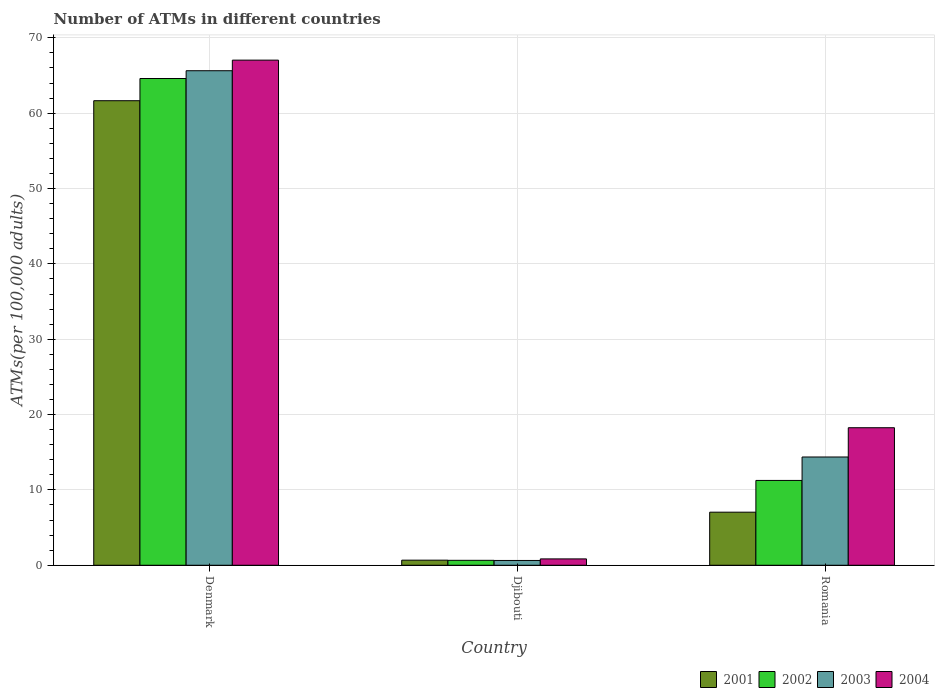How many groups of bars are there?
Provide a succinct answer. 3. Are the number of bars per tick equal to the number of legend labels?
Make the answer very short. Yes. How many bars are there on the 2nd tick from the left?
Keep it short and to the point. 4. How many bars are there on the 3rd tick from the right?
Make the answer very short. 4. What is the label of the 2nd group of bars from the left?
Keep it short and to the point. Djibouti. What is the number of ATMs in 2004 in Djibouti?
Offer a very short reply. 0.84. Across all countries, what is the maximum number of ATMs in 2002?
Your answer should be compact. 64.61. Across all countries, what is the minimum number of ATMs in 2002?
Your answer should be compact. 0.66. In which country was the number of ATMs in 2003 minimum?
Provide a short and direct response. Djibouti. What is the total number of ATMs in 2001 in the graph?
Keep it short and to the point. 69.38. What is the difference between the number of ATMs in 2004 in Denmark and that in Djibouti?
Make the answer very short. 66.2. What is the difference between the number of ATMs in 2001 in Djibouti and the number of ATMs in 2002 in Denmark?
Keep it short and to the point. -63.93. What is the average number of ATMs in 2001 per country?
Offer a very short reply. 23.13. What is the difference between the number of ATMs of/in 2004 and number of ATMs of/in 2002 in Djibouti?
Offer a terse response. 0.19. What is the ratio of the number of ATMs in 2004 in Djibouti to that in Romania?
Provide a short and direct response. 0.05. Is the difference between the number of ATMs in 2004 in Djibouti and Romania greater than the difference between the number of ATMs in 2002 in Djibouti and Romania?
Offer a terse response. No. What is the difference between the highest and the second highest number of ATMs in 2002?
Provide a succinct answer. 63.95. What is the difference between the highest and the lowest number of ATMs in 2002?
Provide a succinct answer. 63.95. What does the 3rd bar from the left in Denmark represents?
Offer a very short reply. 2003. What does the 3rd bar from the right in Djibouti represents?
Your answer should be very brief. 2002. How many bars are there?
Your response must be concise. 12. How many countries are there in the graph?
Keep it short and to the point. 3. What is the difference between two consecutive major ticks on the Y-axis?
Keep it short and to the point. 10. Are the values on the major ticks of Y-axis written in scientific E-notation?
Offer a terse response. No. Does the graph contain any zero values?
Ensure brevity in your answer.  No. Does the graph contain grids?
Your response must be concise. Yes. Where does the legend appear in the graph?
Give a very brief answer. Bottom right. How many legend labels are there?
Make the answer very short. 4. What is the title of the graph?
Give a very brief answer. Number of ATMs in different countries. What is the label or title of the X-axis?
Give a very brief answer. Country. What is the label or title of the Y-axis?
Offer a very short reply. ATMs(per 100,0 adults). What is the ATMs(per 100,000 adults) of 2001 in Denmark?
Offer a very short reply. 61.66. What is the ATMs(per 100,000 adults) in 2002 in Denmark?
Your answer should be very brief. 64.61. What is the ATMs(per 100,000 adults) of 2003 in Denmark?
Keep it short and to the point. 65.64. What is the ATMs(per 100,000 adults) of 2004 in Denmark?
Make the answer very short. 67.04. What is the ATMs(per 100,000 adults) in 2001 in Djibouti?
Your answer should be very brief. 0.68. What is the ATMs(per 100,000 adults) of 2002 in Djibouti?
Your response must be concise. 0.66. What is the ATMs(per 100,000 adults) of 2003 in Djibouti?
Offer a terse response. 0.64. What is the ATMs(per 100,000 adults) in 2004 in Djibouti?
Give a very brief answer. 0.84. What is the ATMs(per 100,000 adults) in 2001 in Romania?
Provide a succinct answer. 7.04. What is the ATMs(per 100,000 adults) in 2002 in Romania?
Provide a short and direct response. 11.26. What is the ATMs(per 100,000 adults) of 2003 in Romania?
Provide a succinct answer. 14.37. What is the ATMs(per 100,000 adults) of 2004 in Romania?
Your answer should be compact. 18.26. Across all countries, what is the maximum ATMs(per 100,000 adults) of 2001?
Your response must be concise. 61.66. Across all countries, what is the maximum ATMs(per 100,000 adults) in 2002?
Ensure brevity in your answer.  64.61. Across all countries, what is the maximum ATMs(per 100,000 adults) in 2003?
Offer a terse response. 65.64. Across all countries, what is the maximum ATMs(per 100,000 adults) of 2004?
Keep it short and to the point. 67.04. Across all countries, what is the minimum ATMs(per 100,000 adults) of 2001?
Provide a short and direct response. 0.68. Across all countries, what is the minimum ATMs(per 100,000 adults) of 2002?
Keep it short and to the point. 0.66. Across all countries, what is the minimum ATMs(per 100,000 adults) of 2003?
Provide a succinct answer. 0.64. Across all countries, what is the minimum ATMs(per 100,000 adults) of 2004?
Ensure brevity in your answer.  0.84. What is the total ATMs(per 100,000 adults) of 2001 in the graph?
Provide a succinct answer. 69.38. What is the total ATMs(per 100,000 adults) in 2002 in the graph?
Give a very brief answer. 76.52. What is the total ATMs(per 100,000 adults) in 2003 in the graph?
Give a very brief answer. 80.65. What is the total ATMs(per 100,000 adults) of 2004 in the graph?
Your answer should be compact. 86.14. What is the difference between the ATMs(per 100,000 adults) in 2001 in Denmark and that in Djibouti?
Your answer should be very brief. 60.98. What is the difference between the ATMs(per 100,000 adults) of 2002 in Denmark and that in Djibouti?
Give a very brief answer. 63.95. What is the difference between the ATMs(per 100,000 adults) of 2003 in Denmark and that in Djibouti?
Offer a very short reply. 65. What is the difference between the ATMs(per 100,000 adults) in 2004 in Denmark and that in Djibouti?
Make the answer very short. 66.2. What is the difference between the ATMs(per 100,000 adults) of 2001 in Denmark and that in Romania?
Give a very brief answer. 54.61. What is the difference between the ATMs(per 100,000 adults) of 2002 in Denmark and that in Romania?
Offer a terse response. 53.35. What is the difference between the ATMs(per 100,000 adults) of 2003 in Denmark and that in Romania?
Your answer should be very brief. 51.27. What is the difference between the ATMs(per 100,000 adults) of 2004 in Denmark and that in Romania?
Give a very brief answer. 48.79. What is the difference between the ATMs(per 100,000 adults) in 2001 in Djibouti and that in Romania?
Your answer should be compact. -6.37. What is the difference between the ATMs(per 100,000 adults) of 2002 in Djibouti and that in Romania?
Keep it short and to the point. -10.6. What is the difference between the ATMs(per 100,000 adults) in 2003 in Djibouti and that in Romania?
Give a very brief answer. -13.73. What is the difference between the ATMs(per 100,000 adults) of 2004 in Djibouti and that in Romania?
Offer a very short reply. -17.41. What is the difference between the ATMs(per 100,000 adults) of 2001 in Denmark and the ATMs(per 100,000 adults) of 2002 in Djibouti?
Make the answer very short. 61. What is the difference between the ATMs(per 100,000 adults) of 2001 in Denmark and the ATMs(per 100,000 adults) of 2003 in Djibouti?
Keep it short and to the point. 61.02. What is the difference between the ATMs(per 100,000 adults) in 2001 in Denmark and the ATMs(per 100,000 adults) in 2004 in Djibouti?
Your response must be concise. 60.81. What is the difference between the ATMs(per 100,000 adults) in 2002 in Denmark and the ATMs(per 100,000 adults) in 2003 in Djibouti?
Provide a short and direct response. 63.97. What is the difference between the ATMs(per 100,000 adults) of 2002 in Denmark and the ATMs(per 100,000 adults) of 2004 in Djibouti?
Make the answer very short. 63.76. What is the difference between the ATMs(per 100,000 adults) of 2003 in Denmark and the ATMs(per 100,000 adults) of 2004 in Djibouti?
Make the answer very short. 64.79. What is the difference between the ATMs(per 100,000 adults) in 2001 in Denmark and the ATMs(per 100,000 adults) in 2002 in Romania?
Offer a very short reply. 50.4. What is the difference between the ATMs(per 100,000 adults) of 2001 in Denmark and the ATMs(per 100,000 adults) of 2003 in Romania?
Provide a succinct answer. 47.29. What is the difference between the ATMs(per 100,000 adults) of 2001 in Denmark and the ATMs(per 100,000 adults) of 2004 in Romania?
Your answer should be compact. 43.4. What is the difference between the ATMs(per 100,000 adults) in 2002 in Denmark and the ATMs(per 100,000 adults) in 2003 in Romania?
Offer a terse response. 50.24. What is the difference between the ATMs(per 100,000 adults) in 2002 in Denmark and the ATMs(per 100,000 adults) in 2004 in Romania?
Offer a very short reply. 46.35. What is the difference between the ATMs(per 100,000 adults) of 2003 in Denmark and the ATMs(per 100,000 adults) of 2004 in Romania?
Your answer should be very brief. 47.38. What is the difference between the ATMs(per 100,000 adults) in 2001 in Djibouti and the ATMs(per 100,000 adults) in 2002 in Romania?
Make the answer very short. -10.58. What is the difference between the ATMs(per 100,000 adults) in 2001 in Djibouti and the ATMs(per 100,000 adults) in 2003 in Romania?
Give a very brief answer. -13.69. What is the difference between the ATMs(per 100,000 adults) in 2001 in Djibouti and the ATMs(per 100,000 adults) in 2004 in Romania?
Give a very brief answer. -17.58. What is the difference between the ATMs(per 100,000 adults) in 2002 in Djibouti and the ATMs(per 100,000 adults) in 2003 in Romania?
Make the answer very short. -13.71. What is the difference between the ATMs(per 100,000 adults) of 2002 in Djibouti and the ATMs(per 100,000 adults) of 2004 in Romania?
Keep it short and to the point. -17.6. What is the difference between the ATMs(per 100,000 adults) of 2003 in Djibouti and the ATMs(per 100,000 adults) of 2004 in Romania?
Give a very brief answer. -17.62. What is the average ATMs(per 100,000 adults) of 2001 per country?
Your answer should be compact. 23.13. What is the average ATMs(per 100,000 adults) in 2002 per country?
Offer a terse response. 25.51. What is the average ATMs(per 100,000 adults) in 2003 per country?
Give a very brief answer. 26.88. What is the average ATMs(per 100,000 adults) of 2004 per country?
Make the answer very short. 28.71. What is the difference between the ATMs(per 100,000 adults) in 2001 and ATMs(per 100,000 adults) in 2002 in Denmark?
Make the answer very short. -2.95. What is the difference between the ATMs(per 100,000 adults) of 2001 and ATMs(per 100,000 adults) of 2003 in Denmark?
Offer a terse response. -3.98. What is the difference between the ATMs(per 100,000 adults) in 2001 and ATMs(per 100,000 adults) in 2004 in Denmark?
Give a very brief answer. -5.39. What is the difference between the ATMs(per 100,000 adults) in 2002 and ATMs(per 100,000 adults) in 2003 in Denmark?
Your answer should be compact. -1.03. What is the difference between the ATMs(per 100,000 adults) of 2002 and ATMs(per 100,000 adults) of 2004 in Denmark?
Provide a succinct answer. -2.44. What is the difference between the ATMs(per 100,000 adults) in 2003 and ATMs(per 100,000 adults) in 2004 in Denmark?
Ensure brevity in your answer.  -1.41. What is the difference between the ATMs(per 100,000 adults) of 2001 and ATMs(per 100,000 adults) of 2002 in Djibouti?
Your answer should be compact. 0.02. What is the difference between the ATMs(per 100,000 adults) of 2001 and ATMs(per 100,000 adults) of 2003 in Djibouti?
Provide a short and direct response. 0.04. What is the difference between the ATMs(per 100,000 adults) of 2001 and ATMs(per 100,000 adults) of 2004 in Djibouti?
Your response must be concise. -0.17. What is the difference between the ATMs(per 100,000 adults) in 2002 and ATMs(per 100,000 adults) in 2003 in Djibouti?
Provide a succinct answer. 0.02. What is the difference between the ATMs(per 100,000 adults) of 2002 and ATMs(per 100,000 adults) of 2004 in Djibouti?
Your answer should be very brief. -0.19. What is the difference between the ATMs(per 100,000 adults) of 2003 and ATMs(per 100,000 adults) of 2004 in Djibouti?
Your answer should be compact. -0.21. What is the difference between the ATMs(per 100,000 adults) in 2001 and ATMs(per 100,000 adults) in 2002 in Romania?
Keep it short and to the point. -4.21. What is the difference between the ATMs(per 100,000 adults) of 2001 and ATMs(per 100,000 adults) of 2003 in Romania?
Ensure brevity in your answer.  -7.32. What is the difference between the ATMs(per 100,000 adults) in 2001 and ATMs(per 100,000 adults) in 2004 in Romania?
Your answer should be compact. -11.21. What is the difference between the ATMs(per 100,000 adults) of 2002 and ATMs(per 100,000 adults) of 2003 in Romania?
Make the answer very short. -3.11. What is the difference between the ATMs(per 100,000 adults) in 2002 and ATMs(per 100,000 adults) in 2004 in Romania?
Ensure brevity in your answer.  -7. What is the difference between the ATMs(per 100,000 adults) of 2003 and ATMs(per 100,000 adults) of 2004 in Romania?
Your answer should be compact. -3.89. What is the ratio of the ATMs(per 100,000 adults) in 2001 in Denmark to that in Djibouti?
Give a very brief answer. 91.18. What is the ratio of the ATMs(per 100,000 adults) of 2002 in Denmark to that in Djibouti?
Your answer should be compact. 98.45. What is the ratio of the ATMs(per 100,000 adults) in 2003 in Denmark to that in Djibouti?
Ensure brevity in your answer.  102.88. What is the ratio of the ATMs(per 100,000 adults) in 2004 in Denmark to that in Djibouti?
Your answer should be compact. 79.46. What is the ratio of the ATMs(per 100,000 adults) in 2001 in Denmark to that in Romania?
Make the answer very short. 8.75. What is the ratio of the ATMs(per 100,000 adults) of 2002 in Denmark to that in Romania?
Your answer should be compact. 5.74. What is the ratio of the ATMs(per 100,000 adults) of 2003 in Denmark to that in Romania?
Provide a succinct answer. 4.57. What is the ratio of the ATMs(per 100,000 adults) of 2004 in Denmark to that in Romania?
Offer a very short reply. 3.67. What is the ratio of the ATMs(per 100,000 adults) of 2001 in Djibouti to that in Romania?
Provide a succinct answer. 0.1. What is the ratio of the ATMs(per 100,000 adults) of 2002 in Djibouti to that in Romania?
Provide a succinct answer. 0.06. What is the ratio of the ATMs(per 100,000 adults) of 2003 in Djibouti to that in Romania?
Keep it short and to the point. 0.04. What is the ratio of the ATMs(per 100,000 adults) of 2004 in Djibouti to that in Romania?
Keep it short and to the point. 0.05. What is the difference between the highest and the second highest ATMs(per 100,000 adults) in 2001?
Keep it short and to the point. 54.61. What is the difference between the highest and the second highest ATMs(per 100,000 adults) in 2002?
Keep it short and to the point. 53.35. What is the difference between the highest and the second highest ATMs(per 100,000 adults) in 2003?
Your answer should be very brief. 51.27. What is the difference between the highest and the second highest ATMs(per 100,000 adults) of 2004?
Make the answer very short. 48.79. What is the difference between the highest and the lowest ATMs(per 100,000 adults) in 2001?
Provide a succinct answer. 60.98. What is the difference between the highest and the lowest ATMs(per 100,000 adults) of 2002?
Keep it short and to the point. 63.95. What is the difference between the highest and the lowest ATMs(per 100,000 adults) of 2003?
Offer a terse response. 65. What is the difference between the highest and the lowest ATMs(per 100,000 adults) of 2004?
Provide a short and direct response. 66.2. 